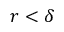<formula> <loc_0><loc_0><loc_500><loc_500>r < \delta</formula> 